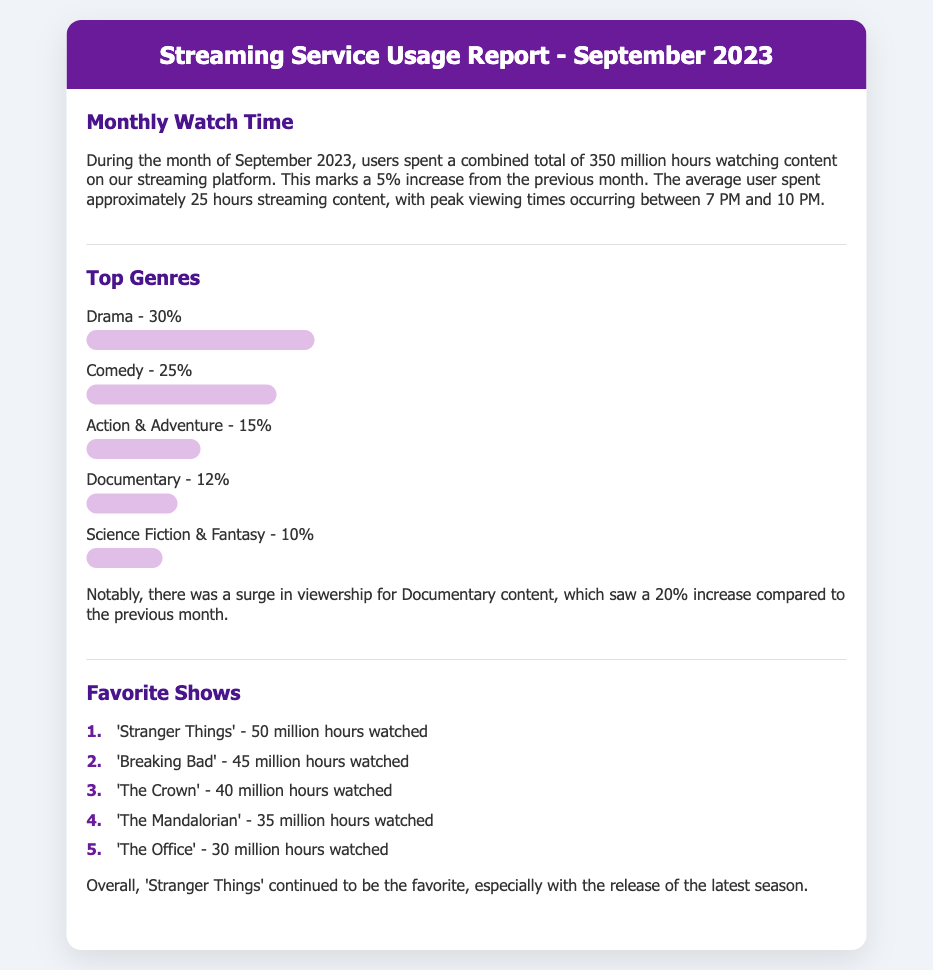what was the total watch time in September 2023? The total watch time is mentioned as 350 million hours for the month of September 2023.
Answer: 350 million hours what was the percentage increase in watch time from the previous month? The document states that watch time increased by 5% from the previous month.
Answer: 5% which genre had the highest percentage of viewership? The genre with the highest percentage is Drama, which accounts for 30% of viewership.
Answer: Drama what is the total hours watched for the show 'Breaking Bad'? The document specifies that 'Breaking Bad' was watched for 45 million hours.
Answer: 45 million hours which genre saw a 20% increase in viewership? The document notes that Documentary content saw a surge in viewership, which was a 20% increase.
Answer: Documentary how many hours was 'Stranger Things' watched? 'Stranger Things' was watched for 50 million hours according to the report.
Answer: 50 million hours what time period had peak viewing? The peak viewing times mentioned are between 7 PM and 10 PM.
Answer: 7 PM and 10 PM how many total genres were listed in the report? The report lists a total of five different genres.
Answer: five what is the rank of 'The Crown' in favorite shows? 'The Crown' is ranked 3rd among the favorite shows.
Answer: 3rd 